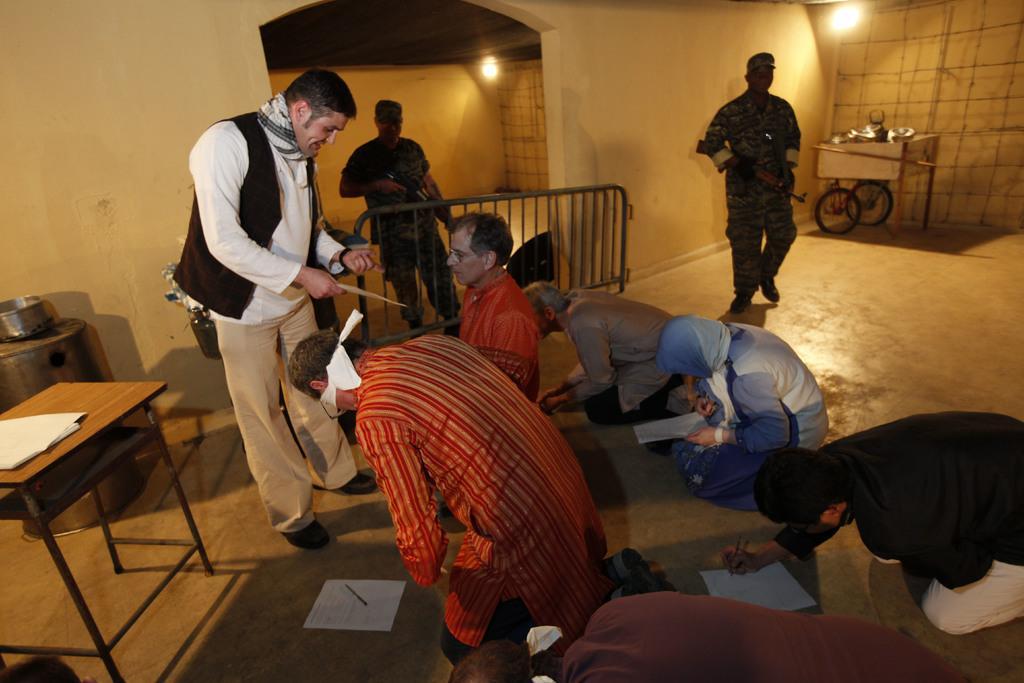How would you summarize this image in a sentence or two? In this image we can see there are a group of people, a few among them are kneeling down and writing and two among them are holding guns, behind them there is a fence, a trolley and lights, on the left side of the image there are tables and a few other objects. 